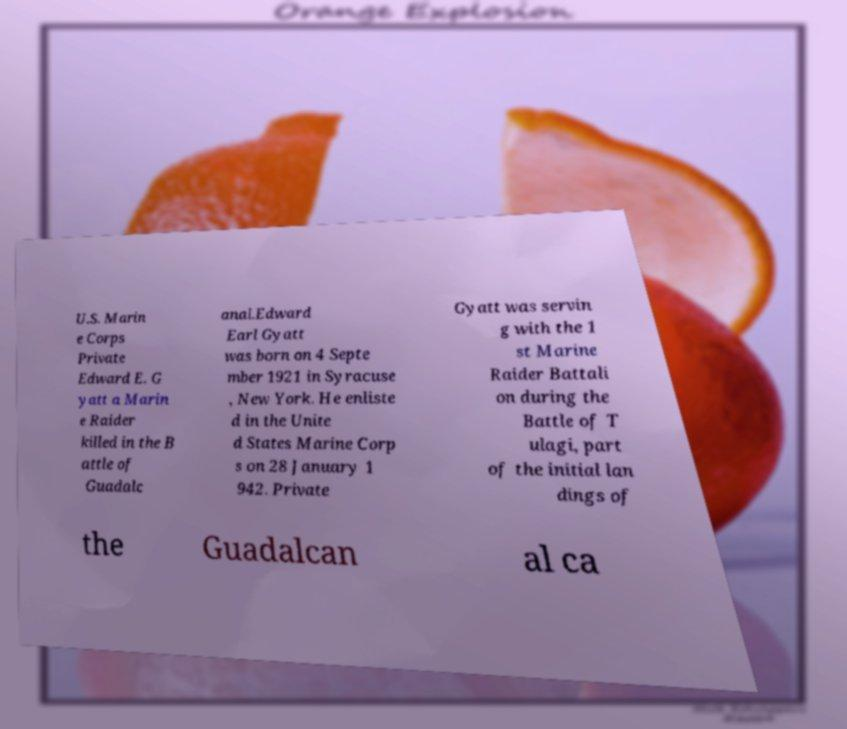Could you assist in decoding the text presented in this image and type it out clearly? U.S. Marin e Corps Private Edward E. G yatt a Marin e Raider killed in the B attle of Guadalc anal.Edward Earl Gyatt was born on 4 Septe mber 1921 in Syracuse , New York. He enliste d in the Unite d States Marine Corp s on 28 January 1 942. Private Gyatt was servin g with the 1 st Marine Raider Battali on during the Battle of T ulagi, part of the initial lan dings of the Guadalcan al ca 